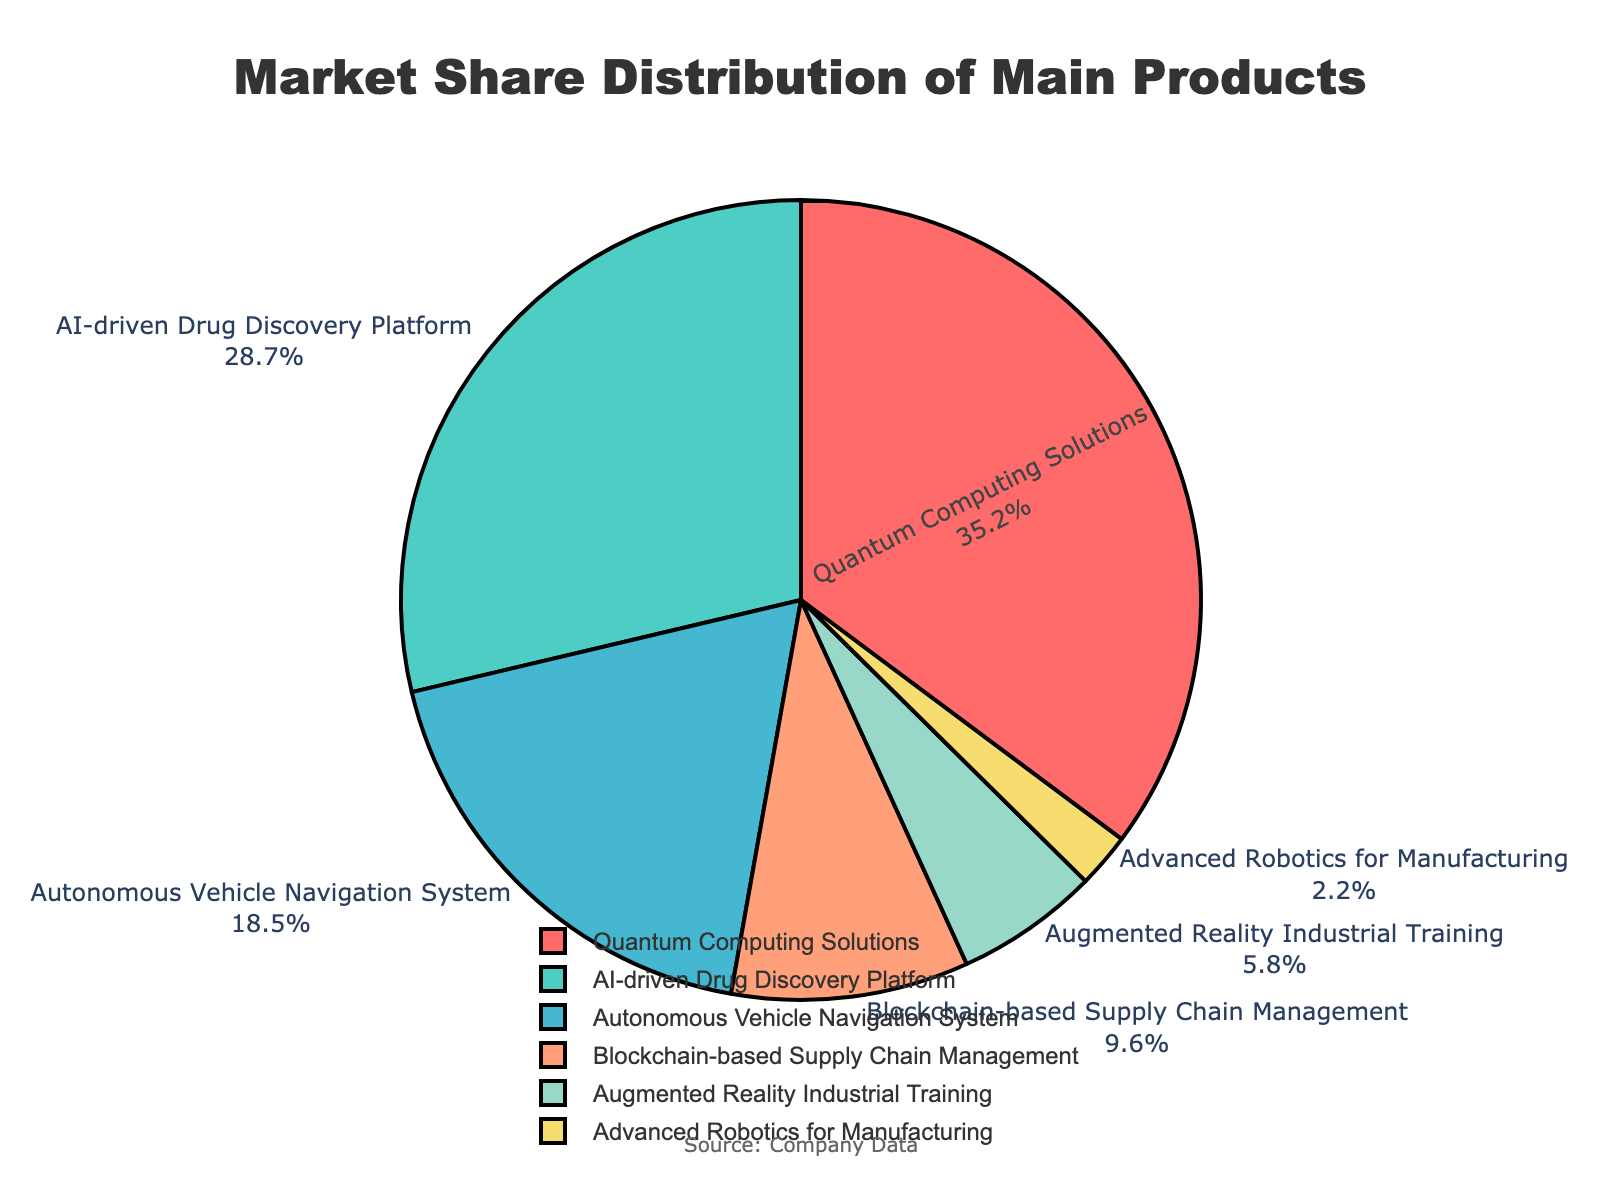What is the product with the largest market share? The product with the largest market share can be identified by looking for the segment with the highest percentage in the pie chart. The "Quantum Computing Solutions" segment, which has the largest area (35.2%), is the largest market share.
Answer: Quantum Computing Solutions Which product has roughly one-third of the market share? To find the product with roughly one-third of the market share, we look for a segment close to 33.3%. The "Quantum Computing Solutions" segment, representing 35.2%, is closest to one-third.
Answer: Quantum Computing Solutions How much more market share does the AI-driven Drug Discovery Platform have compared to the Blockchain-based Supply Chain Management? To find the difference, subtract the market share of the Blockchain-based Supply Chain Management (9.6%) from that of the AI-driven Drug Discovery Platform (28.7%). The calculation is 28.7% - 9.6% = 19.1%.
Answer: 19.1% Combine the market share of the Autonomous Vehicle Navigation System and Advanced Robotics for Manufacturing. What is the total? Add the market shares of the Autonomous Vehicle Navigation System (18.5%) and Advanced Robotics for Manufacturing (2.2%). The total is 18.5% + 2.2% = 20.7%.
Answer: 20.7% Which products together make up more than half of the total market share? To determine which segments together exceed 50%, sum the market shares from the largest segment downwards until the sum is over 50%. The combined market share of "Quantum Computing Solutions" (35.2%) and "AI-driven Drug Discovery Platform" (28.7%) is 35.2% + 28.7% = 63.9%.
Answer: Quantum Computing Solutions and AI-driven Drug Discovery Platform What is the market share difference between the product with the smallest share and the product with the second smallest share? Identify the product with the smallest share (Advanced Robotics for Manufacturing, 2.2%) and the product with the second smallest share (Augmented Reality Industrial Training, 5.8%). Calculate the difference: 5.8% - 2.2% = 3.6%.
Answer: 3.6% Which products are represented by shades of blue in the pie chart? Look at the segment colors in the pie chart. The colors for the AI-driven Drug Discovery Platform and Advanced Robotics for Manufacturing are shades of blue.
Answer: AI-driven Drug Discovery Platform and Advanced Robotics for Manufacturing Calculate the average market share of AI-driven Drug Discovery Platform and Autonomous Vehicle Navigation System. Add the market shares of AI-driven Drug Discovery Platform (28.7%) and Autonomous Vehicle Navigation System (18.5%), then divide by 2. The calculation is (28.7% + 18.5%) / 2 ≈ 23.6%.
Answer: 23.6% What percentage of the market do combined products with less than 10% share represent? Sum the market shares of products with less than 10%: Blockchain-based Supply Chain Management (9.6%), Augmented Reality Industrial Training (5.8%), and Advanced Robotics for Manufacturing (2.2%). The total is 9.6% + 5.8% + 2.2% = 17.6%.
Answer: 17.6% How does the market share of the Augmented Reality Industrial Training compare to the sum of market shares of Advanced Robotics for Manufacturing and Blockchain-based Supply Chain Management? Calculate the sum of the market shares of Advanced Robotics for Manufacturing (2.2%) and Blockchain-based Supply Chain Management (9.6%): 2.2% + 9.6% = 11.8%. Compare this to the market share of Augmented Reality Industrial Training (5.8%); 11.8% is greater than 5.8%.
Answer: 11.8% is greater than 5.8% 